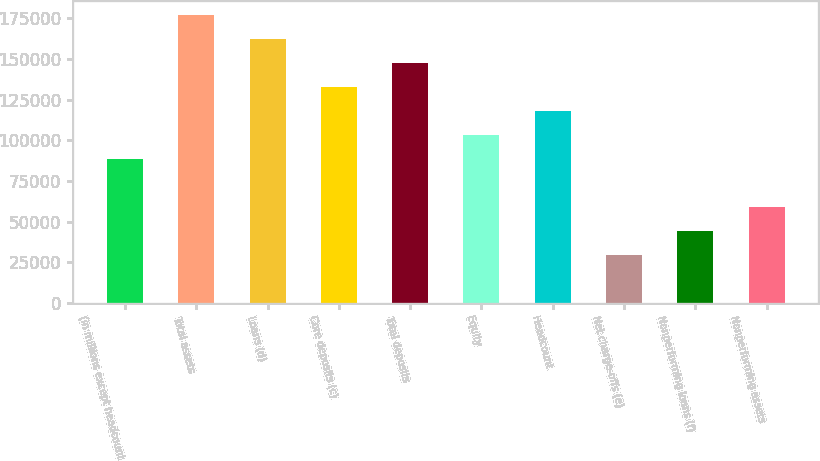<chart> <loc_0><loc_0><loc_500><loc_500><bar_chart><fcel>(in millions except headcount<fcel>Total assets<fcel>Loans (d)<fcel>Core deposits (c)<fcel>Total deposits<fcel>Equity<fcel>Headcount<fcel>Net charge-offs (e)<fcel>Nonperforming loans (f)<fcel>Nonperforming assets<nl><fcel>88461.2<fcel>176922<fcel>162178<fcel>132692<fcel>147435<fcel>103205<fcel>117948<fcel>29487.3<fcel>44230.8<fcel>58974.2<nl></chart> 